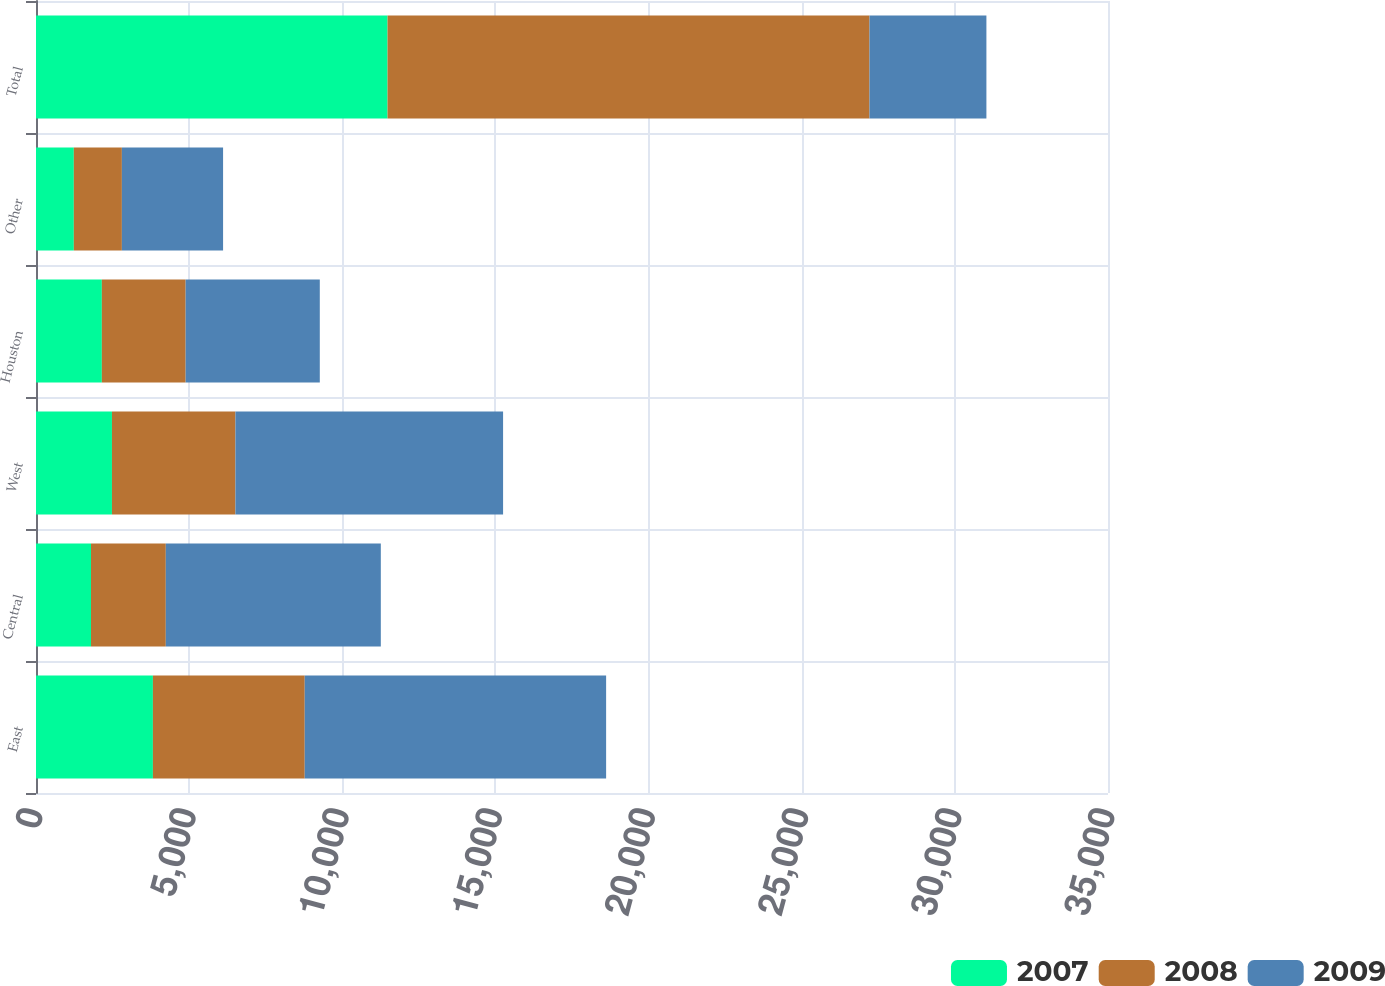Convert chart. <chart><loc_0><loc_0><loc_500><loc_500><stacked_bar_chart><ecel><fcel>East<fcel>Central<fcel>West<fcel>Houston<fcel>Other<fcel>Total<nl><fcel>2007<fcel>3817<fcel>1796<fcel>2480<fcel>2150<fcel>1235<fcel>11478<nl><fcel>2008<fcel>4957<fcel>2442<fcel>4031<fcel>2736<fcel>1569<fcel>15735<nl><fcel>2009<fcel>9840<fcel>7020<fcel>8739<fcel>4380<fcel>3304<fcel>3817<nl></chart> 